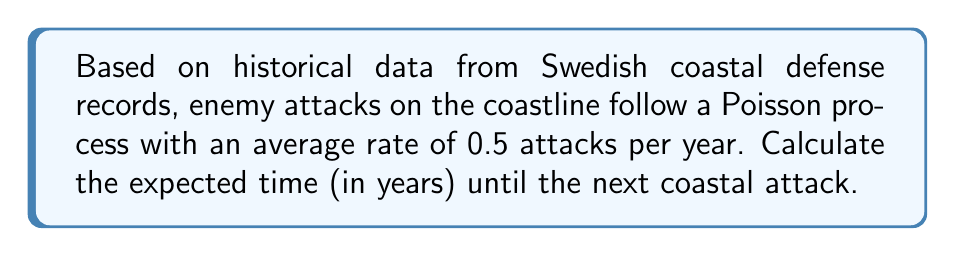Show me your answer to this math problem. Let's approach this step-by-step using the properties of a Poisson process:

1) In a Poisson process, the time between events (in this case, attacks) follows an exponential distribution.

2) The parameter $\lambda$ of the Poisson process is the average rate of events. Here, $\lambda = 0.5$ attacks per year.

3) For an exponential distribution, the expected value (mean) is the reciprocal of the rate parameter:

   $$E[X] = \frac{1}{\lambda}$$

   Where $X$ is the time until the next event.

4) Substituting our value for $\lambda$:

   $$E[X] = \frac{1}{0.5} = 2$$

5) Therefore, the expected time until the next coastal attack is 2 years.

This result aligns with intuition: if there is an average of 0.5 attacks per year, we would expect to wait about 2 years between attacks on average.
Answer: 2 years 